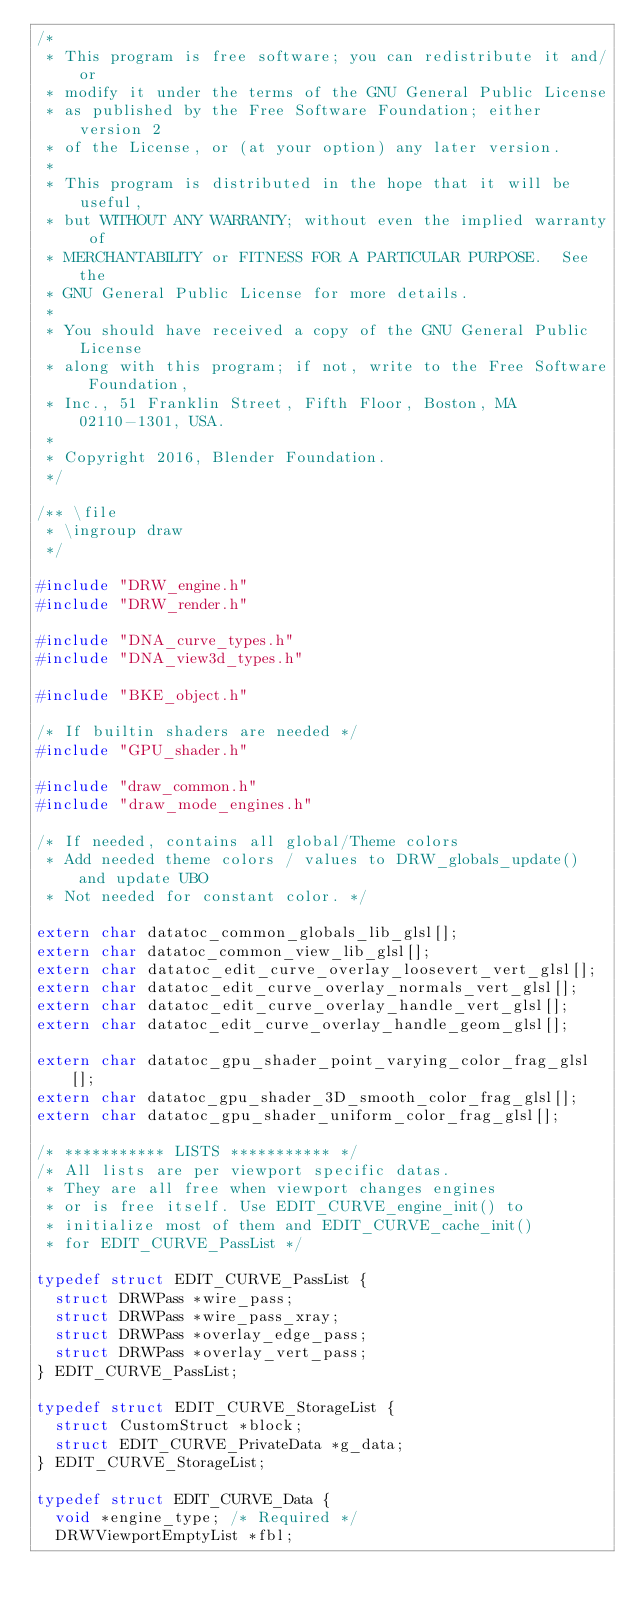Convert code to text. <code><loc_0><loc_0><loc_500><loc_500><_C_>/*
 * This program is free software; you can redistribute it and/or
 * modify it under the terms of the GNU General Public License
 * as published by the Free Software Foundation; either version 2
 * of the License, or (at your option) any later version.
 *
 * This program is distributed in the hope that it will be useful,
 * but WITHOUT ANY WARRANTY; without even the implied warranty of
 * MERCHANTABILITY or FITNESS FOR A PARTICULAR PURPOSE.  See the
 * GNU General Public License for more details.
 *
 * You should have received a copy of the GNU General Public License
 * along with this program; if not, write to the Free Software Foundation,
 * Inc., 51 Franklin Street, Fifth Floor, Boston, MA 02110-1301, USA.
 *
 * Copyright 2016, Blender Foundation.
 */

/** \file
 * \ingroup draw
 */

#include "DRW_engine.h"
#include "DRW_render.h"

#include "DNA_curve_types.h"
#include "DNA_view3d_types.h"

#include "BKE_object.h"

/* If builtin shaders are needed */
#include "GPU_shader.h"

#include "draw_common.h"
#include "draw_mode_engines.h"

/* If needed, contains all global/Theme colors
 * Add needed theme colors / values to DRW_globals_update() and update UBO
 * Not needed for constant color. */

extern char datatoc_common_globals_lib_glsl[];
extern char datatoc_common_view_lib_glsl[];
extern char datatoc_edit_curve_overlay_loosevert_vert_glsl[];
extern char datatoc_edit_curve_overlay_normals_vert_glsl[];
extern char datatoc_edit_curve_overlay_handle_vert_glsl[];
extern char datatoc_edit_curve_overlay_handle_geom_glsl[];

extern char datatoc_gpu_shader_point_varying_color_frag_glsl[];
extern char datatoc_gpu_shader_3D_smooth_color_frag_glsl[];
extern char datatoc_gpu_shader_uniform_color_frag_glsl[];

/* *********** LISTS *********** */
/* All lists are per viewport specific datas.
 * They are all free when viewport changes engines
 * or is free itself. Use EDIT_CURVE_engine_init() to
 * initialize most of them and EDIT_CURVE_cache_init()
 * for EDIT_CURVE_PassList */

typedef struct EDIT_CURVE_PassList {
  struct DRWPass *wire_pass;
  struct DRWPass *wire_pass_xray;
  struct DRWPass *overlay_edge_pass;
  struct DRWPass *overlay_vert_pass;
} EDIT_CURVE_PassList;

typedef struct EDIT_CURVE_StorageList {
  struct CustomStruct *block;
  struct EDIT_CURVE_PrivateData *g_data;
} EDIT_CURVE_StorageList;

typedef struct EDIT_CURVE_Data {
  void *engine_type; /* Required */
  DRWViewportEmptyList *fbl;</code> 